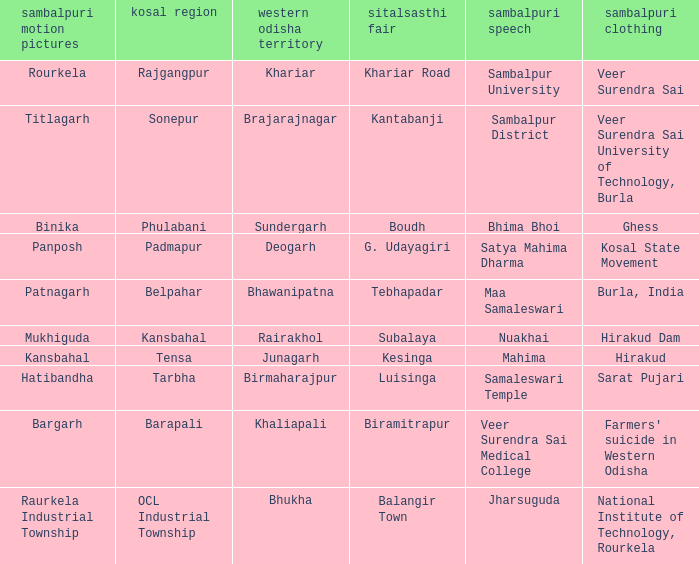What is the sitalsasthi carnival with sonepur as kosal? Kantabanji. 